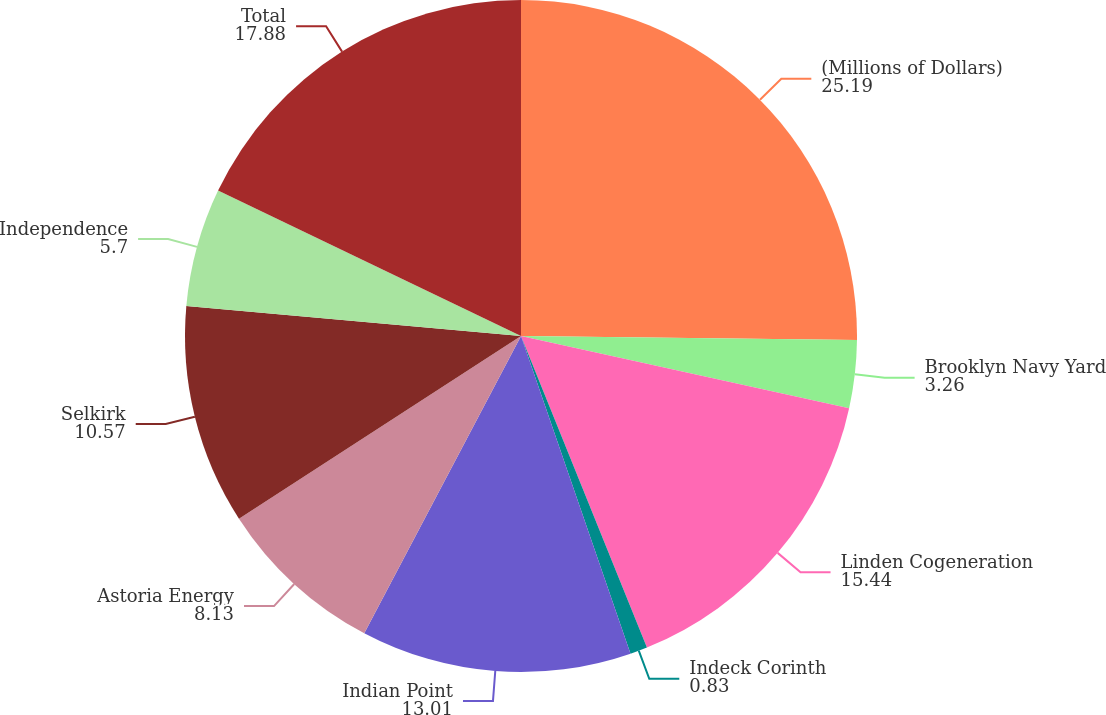<chart> <loc_0><loc_0><loc_500><loc_500><pie_chart><fcel>(Millions of Dollars)<fcel>Brooklyn Navy Yard<fcel>Linden Cogeneration<fcel>Indeck Corinth<fcel>Indian Point<fcel>Astoria Energy<fcel>Selkirk<fcel>Independence<fcel>Total<nl><fcel>25.19%<fcel>3.26%<fcel>15.44%<fcel>0.83%<fcel>13.01%<fcel>8.13%<fcel>10.57%<fcel>5.7%<fcel>17.88%<nl></chart> 